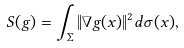Convert formula to latex. <formula><loc_0><loc_0><loc_500><loc_500>S ( g ) = \int _ { \Sigma } \| \nabla g ( x ) \| ^ { 2 } d \sigma ( x ) ,</formula> 